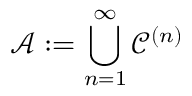<formula> <loc_0><loc_0><loc_500><loc_500>{ \mathcal { A } } \colon = \bigcup _ { n = 1 } ^ { \infty } { \mathcal { C } } ^ { ( n ) }</formula> 